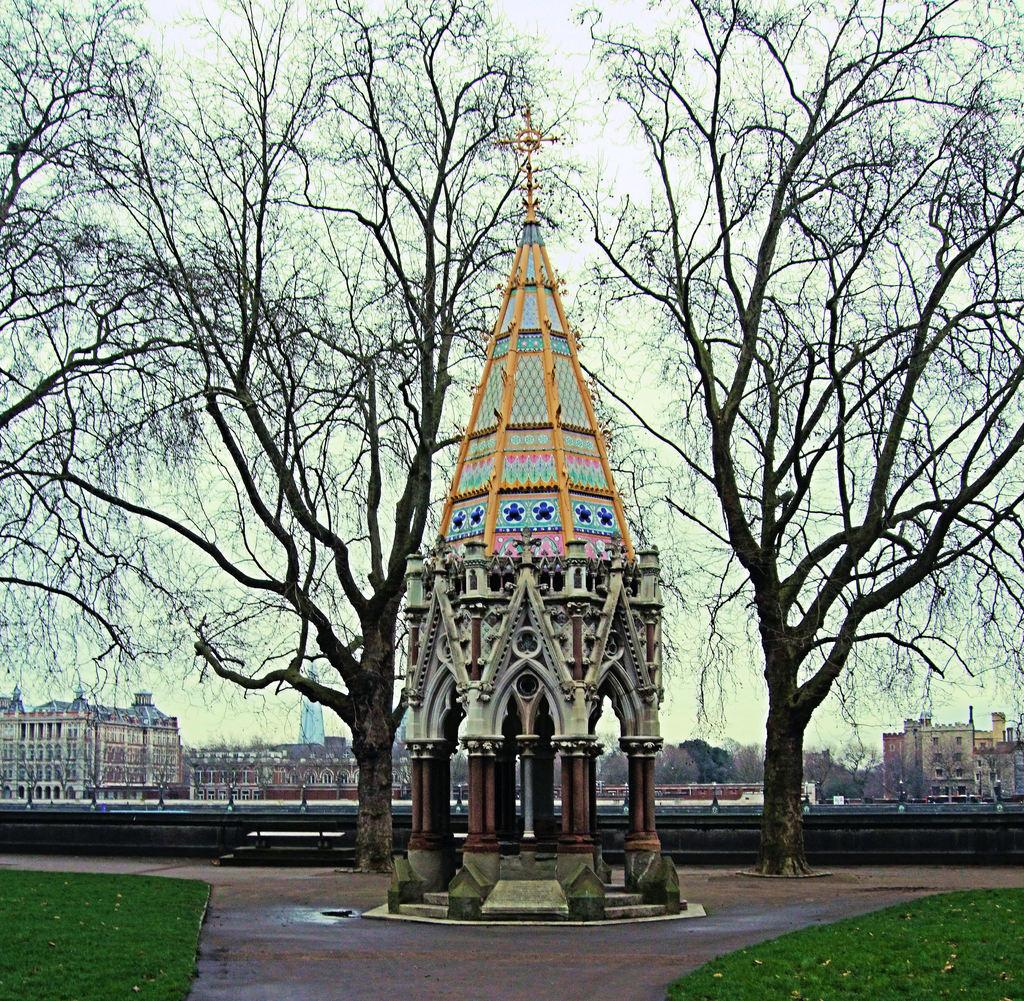What is happening in the middle of the image? There is construction in the middle of the image. What can be seen beside the construction? There are trees beside the construction. What structures are visible at the back side of the image? There are buildings at the back side of the image. What is visible at the top of the image? The sky is visible at the top of the image. Can you see your brother writing with a pen in the window in the image? There is no brother, pen, or window present in the image. 